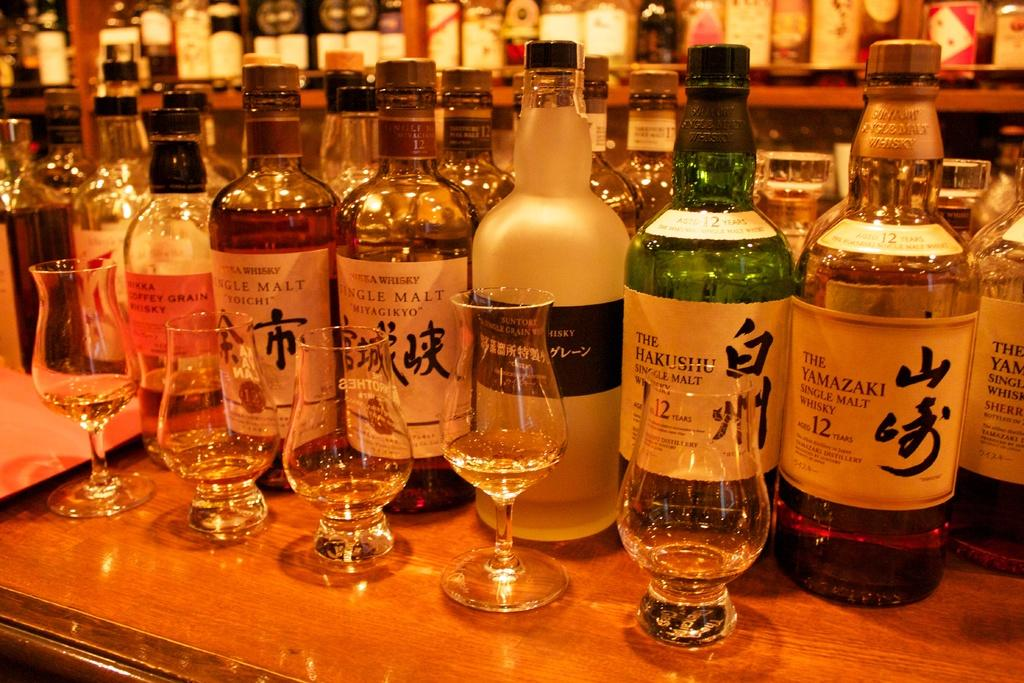<image>
Provide a brief description of the given image. Several different bottles of whisky, including The Yamazaki single malt whiskey, are lined up on a bar, behind empty glasses. 